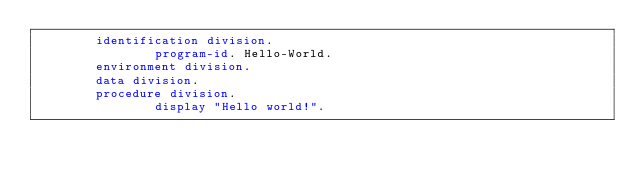Convert code to text. <code><loc_0><loc_0><loc_500><loc_500><_COBOL_>        identification division.
                program-id. Hello-World.
        environment division.
        data division.
        procedure division.
                display "Hello world!".
</code> 